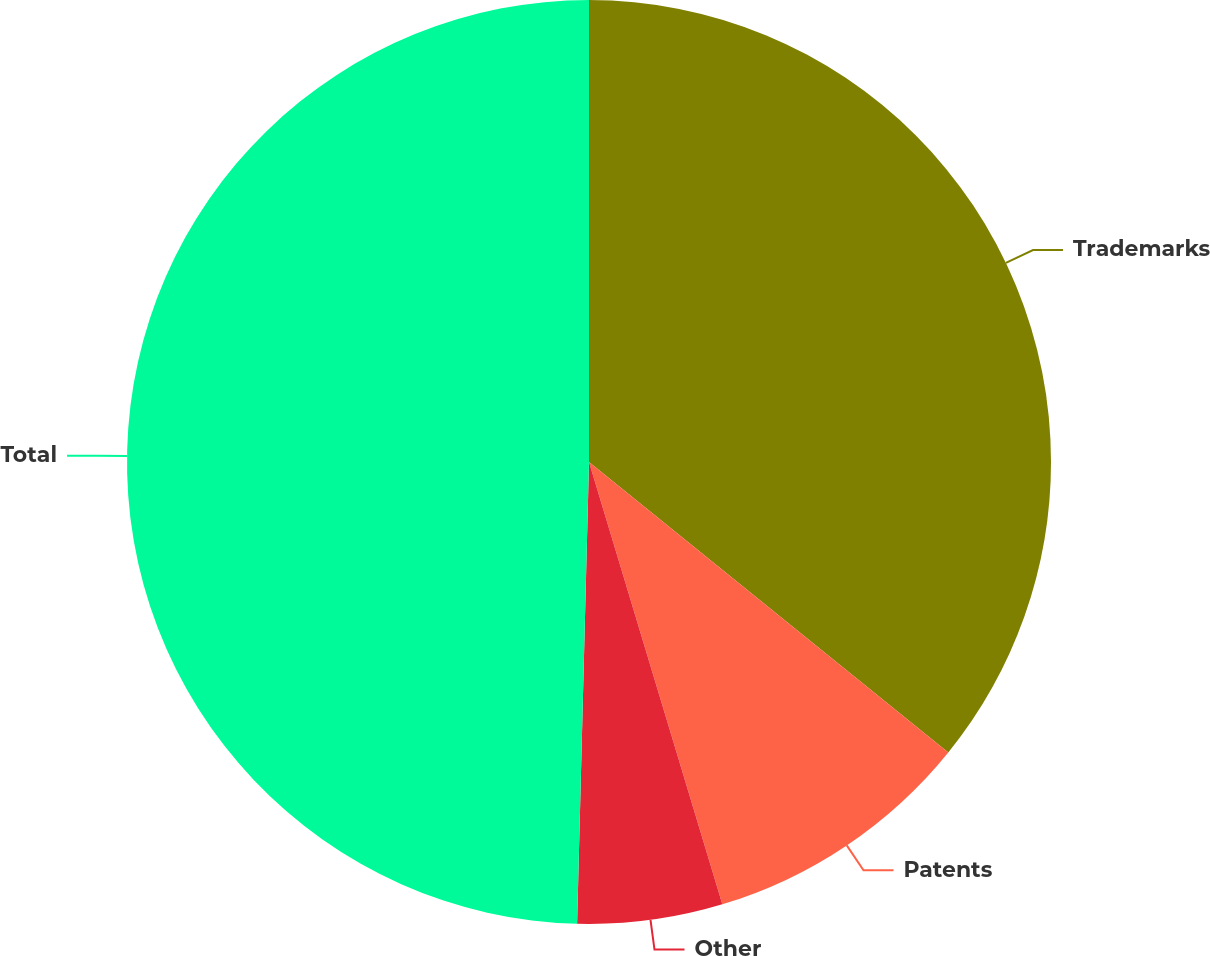<chart> <loc_0><loc_0><loc_500><loc_500><pie_chart><fcel>Trademarks<fcel>Patents<fcel>Other<fcel>Total<nl><fcel>35.82%<fcel>9.52%<fcel>5.07%<fcel>49.59%<nl></chart> 